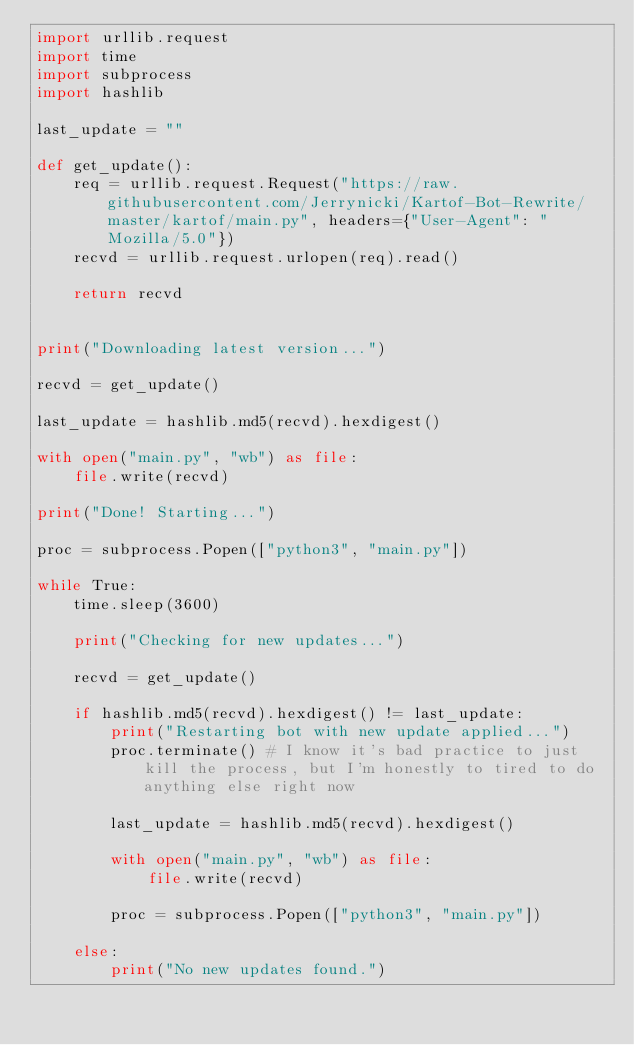<code> <loc_0><loc_0><loc_500><loc_500><_Python_>import urllib.request
import time
import subprocess
import hashlib

last_update = ""

def get_update():
    req = urllib.request.Request("https://raw.githubusercontent.com/Jerrynicki/Kartof-Bot-Rewrite/master/kartof/main.py", headers={"User-Agent": "Mozilla/5.0"})
    recvd = urllib.request.urlopen(req).read()

    return recvd

 
print("Downloading latest version...")

recvd = get_update()

last_update = hashlib.md5(recvd).hexdigest()

with open("main.py", "wb") as file:
    file.write(recvd)

print("Done! Starting...")

proc = subprocess.Popen(["python3", "main.py"])

while True:
    time.sleep(3600)

    print("Checking for new updates...")

    recvd = get_update()

    if hashlib.md5(recvd).hexdigest() != last_update:
        print("Restarting bot with new update applied...")
        proc.terminate() # I know it's bad practice to just kill the process, but I'm honestly to tired to do anything else right now
        
        last_update = hashlib.md5(recvd).hexdigest()

        with open("main.py", "wb") as file:
            file.write(recvd)

        proc = subprocess.Popen(["python3", "main.py"])

    else:
        print("No new updates found.")
</code> 